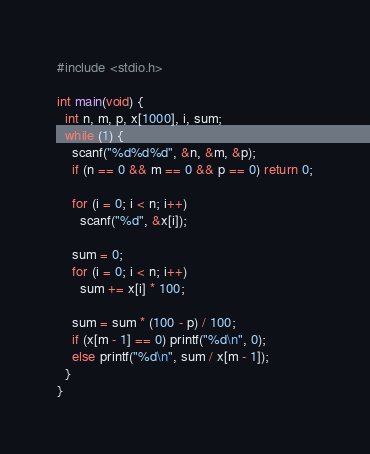<code> <loc_0><loc_0><loc_500><loc_500><_C_>#include <stdio.h>

int main(void) {
  int n, m, p, x[1000], i, sum;
  while (1) {
    scanf("%d%d%d", &n, &m, &p);
    if (n == 0 && m == 0 && p == 0) return 0;

    for (i = 0; i < n; i++)
      scanf("%d", &x[i]);

    sum = 0;
    for (i = 0; i < n; i++)
      sum += x[i] * 100;

    sum = sum * (100 - p) / 100;
    if (x[m - 1] == 0) printf("%d\n", 0);
    else printf("%d\n", sum / x[m - 1]);
  }
}</code> 